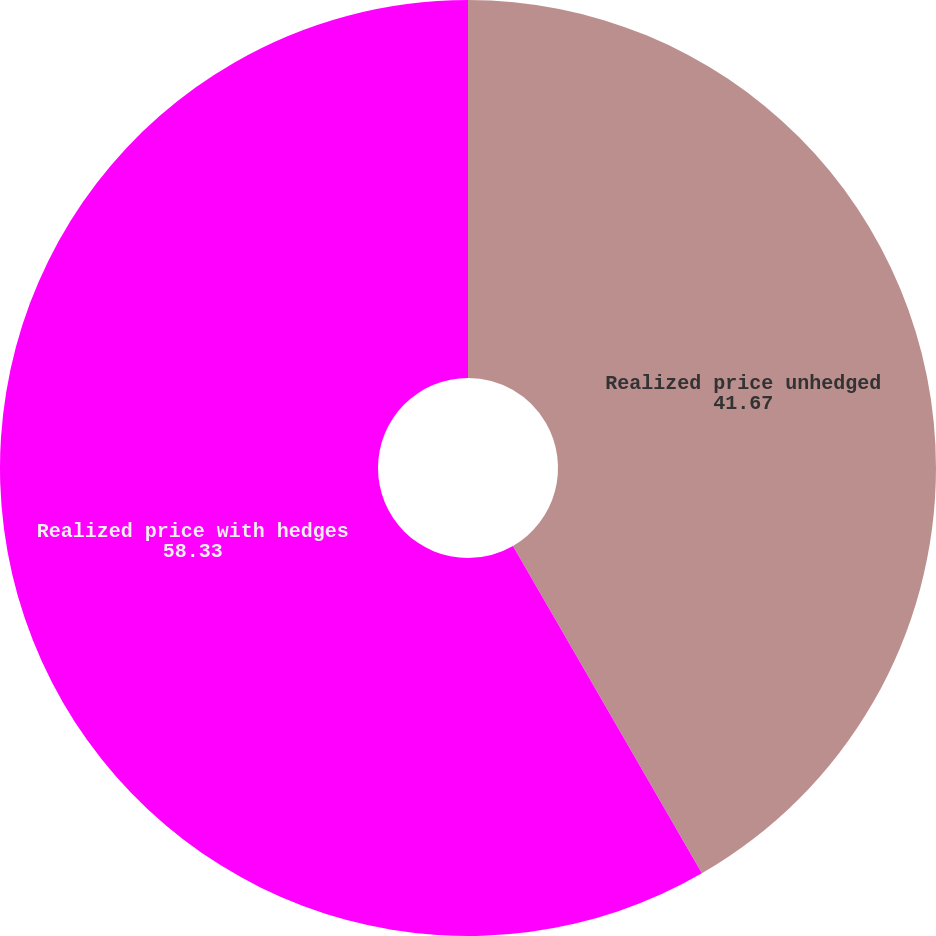Convert chart to OTSL. <chart><loc_0><loc_0><loc_500><loc_500><pie_chart><fcel>Realized price unhedged<fcel>Realized price with hedges<nl><fcel>41.67%<fcel>58.33%<nl></chart> 